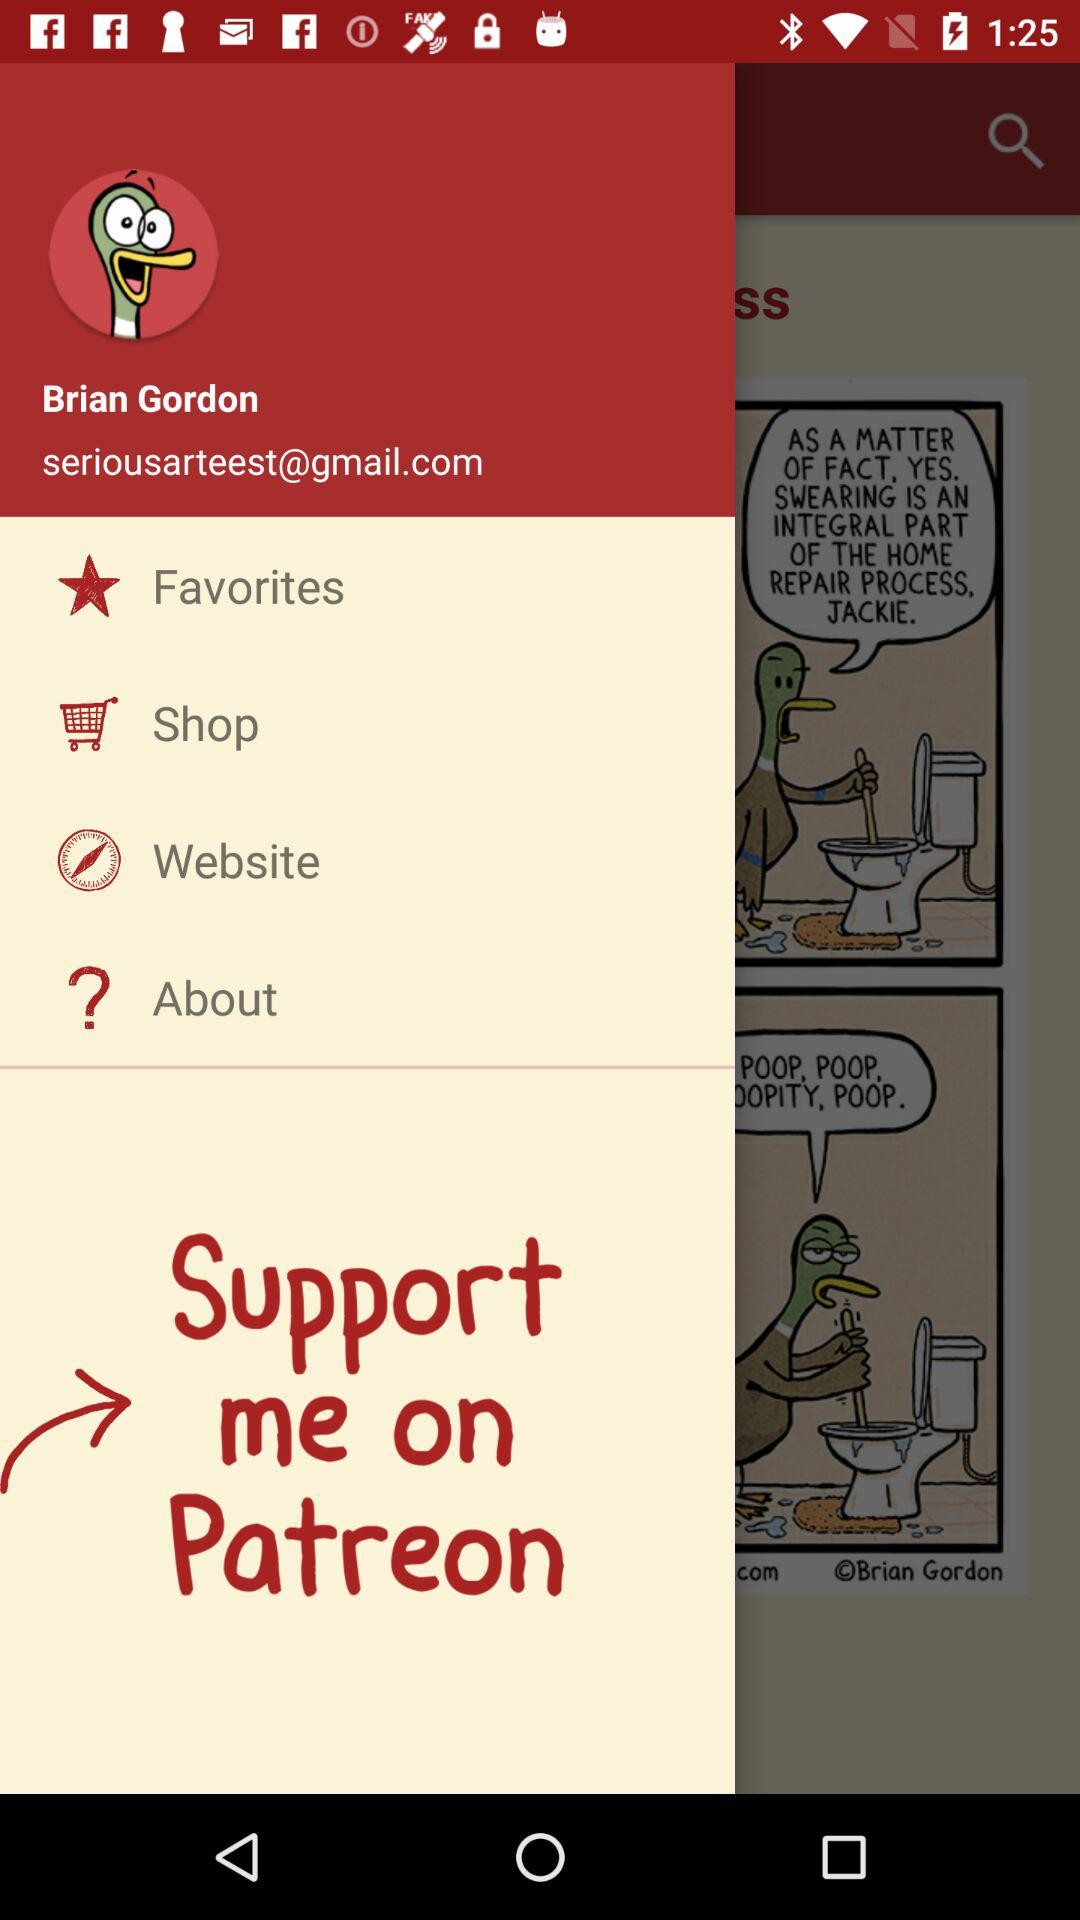Where can the user give support? The user can give support on "Patreon". 